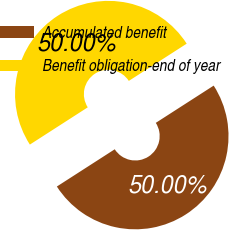Convert chart. <chart><loc_0><loc_0><loc_500><loc_500><pie_chart><fcel>Accumulated benefit<fcel>Benefit obligation-end of year<nl><fcel>50.0%<fcel>50.0%<nl></chart> 